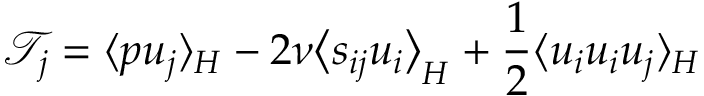<formula> <loc_0><loc_0><loc_500><loc_500>\mathcal { T } _ { j } = \langle p u _ { j } \rangle _ { H } - 2 \nu \left \langle s _ { i j } u _ { i } \right \rangle _ { H } + \frac { 1 } { 2 } \langle u _ { i } u _ { i } u _ { j } \rangle _ { H }</formula> 